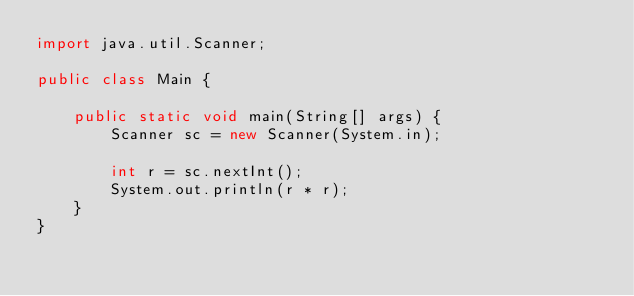<code> <loc_0><loc_0><loc_500><loc_500><_Java_>import java.util.Scanner;

public class Main {

    public static void main(String[] args) {
        Scanner sc = new Scanner(System.in);

        int r = sc.nextInt();
        System.out.println(r * r);
    }
}</code> 